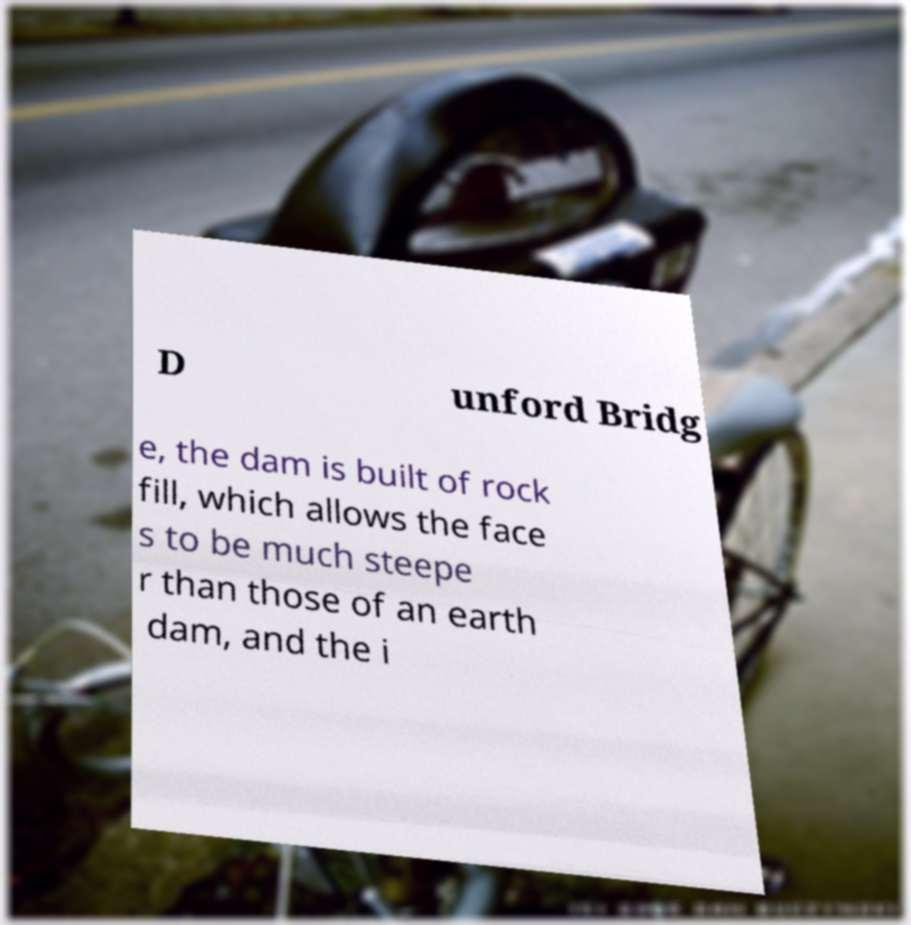Could you assist in decoding the text presented in this image and type it out clearly? D unford Bridg e, the dam is built of rock fill, which allows the face s to be much steepe r than those of an earth dam, and the i 